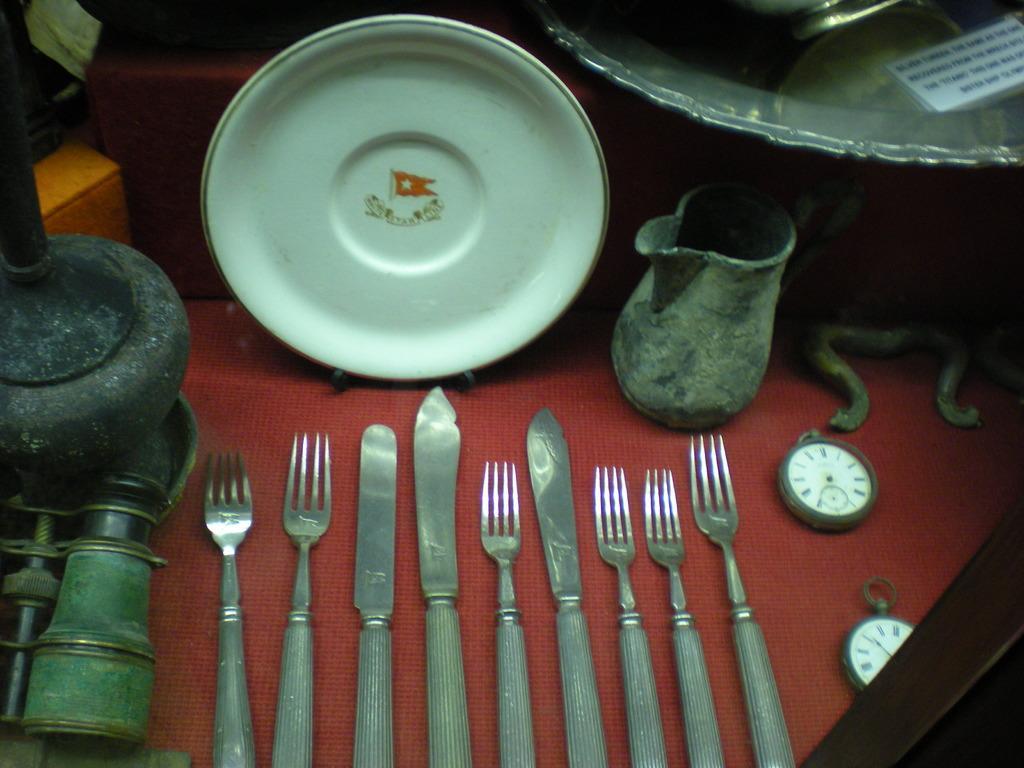Could you give a brief overview of what you see in this image? In this picture we can see a plate, jug, clocks, forks, knives and some objects and these all are placed on a surface. 